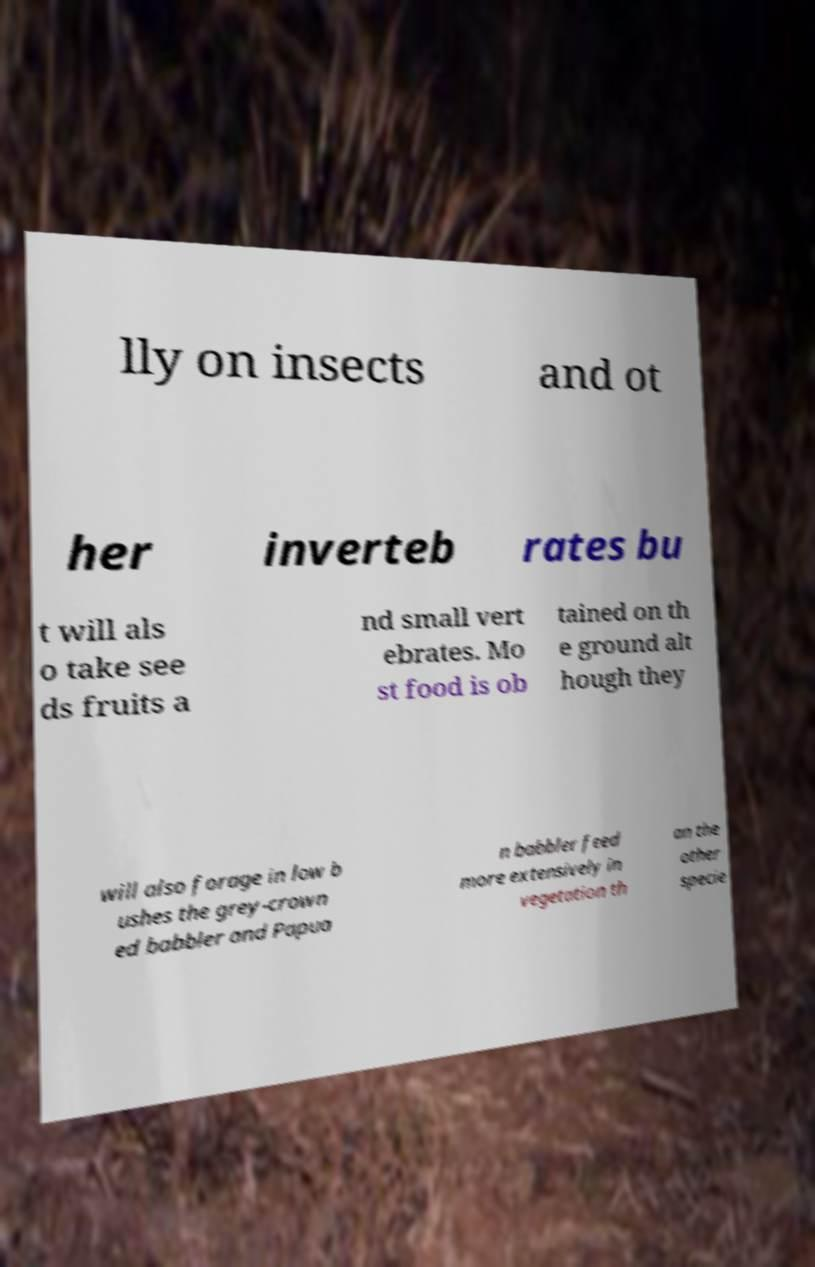Could you extract and type out the text from this image? lly on insects and ot her inverteb rates bu t will als o take see ds fruits a nd small vert ebrates. Mo st food is ob tained on th e ground alt hough they will also forage in low b ushes the grey-crown ed babbler and Papua n babbler feed more extensively in vegetation th an the other specie 